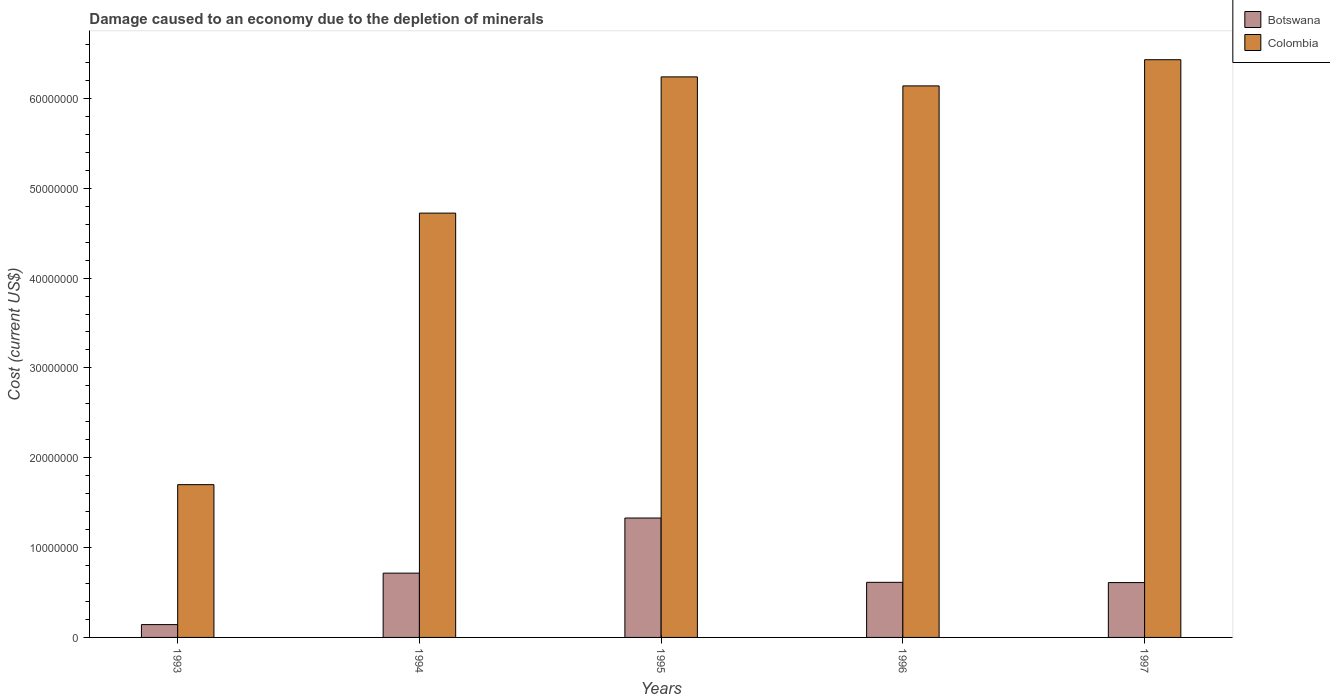What is the label of the 1st group of bars from the left?
Provide a short and direct response. 1993. What is the cost of damage caused due to the depletion of minerals in Botswana in 1993?
Provide a short and direct response. 1.43e+06. Across all years, what is the maximum cost of damage caused due to the depletion of minerals in Botswana?
Ensure brevity in your answer.  1.33e+07. Across all years, what is the minimum cost of damage caused due to the depletion of minerals in Colombia?
Ensure brevity in your answer.  1.70e+07. What is the total cost of damage caused due to the depletion of minerals in Colombia in the graph?
Give a very brief answer. 2.52e+08. What is the difference between the cost of damage caused due to the depletion of minerals in Botswana in 1994 and that in 1996?
Offer a very short reply. 1.02e+06. What is the difference between the cost of damage caused due to the depletion of minerals in Botswana in 1996 and the cost of damage caused due to the depletion of minerals in Colombia in 1994?
Your answer should be compact. -4.11e+07. What is the average cost of damage caused due to the depletion of minerals in Botswana per year?
Provide a short and direct response. 6.82e+06. In the year 1997, what is the difference between the cost of damage caused due to the depletion of minerals in Colombia and cost of damage caused due to the depletion of minerals in Botswana?
Ensure brevity in your answer.  5.82e+07. In how many years, is the cost of damage caused due to the depletion of minerals in Colombia greater than 46000000 US$?
Give a very brief answer. 4. What is the ratio of the cost of damage caused due to the depletion of minerals in Botswana in 1995 to that in 1996?
Make the answer very short. 2.17. Is the difference between the cost of damage caused due to the depletion of minerals in Colombia in 1994 and 1995 greater than the difference between the cost of damage caused due to the depletion of minerals in Botswana in 1994 and 1995?
Provide a short and direct response. No. What is the difference between the highest and the second highest cost of damage caused due to the depletion of minerals in Botswana?
Ensure brevity in your answer.  6.13e+06. What is the difference between the highest and the lowest cost of damage caused due to the depletion of minerals in Colombia?
Ensure brevity in your answer.  4.73e+07. What does the 1st bar from the left in 1997 represents?
Make the answer very short. Botswana. What does the 2nd bar from the right in 1995 represents?
Offer a very short reply. Botswana. How many bars are there?
Give a very brief answer. 10. Are all the bars in the graph horizontal?
Provide a succinct answer. No. Are the values on the major ticks of Y-axis written in scientific E-notation?
Ensure brevity in your answer.  No. Does the graph contain any zero values?
Your answer should be very brief. No. Does the graph contain grids?
Keep it short and to the point. No. How many legend labels are there?
Offer a very short reply. 2. What is the title of the graph?
Give a very brief answer. Damage caused to an economy due to the depletion of minerals. What is the label or title of the Y-axis?
Your answer should be compact. Cost (current US$). What is the Cost (current US$) in Botswana in 1993?
Give a very brief answer. 1.43e+06. What is the Cost (current US$) of Colombia in 1993?
Give a very brief answer. 1.70e+07. What is the Cost (current US$) of Botswana in 1994?
Give a very brief answer. 7.16e+06. What is the Cost (current US$) of Colombia in 1994?
Your answer should be very brief. 4.72e+07. What is the Cost (current US$) of Botswana in 1995?
Offer a very short reply. 1.33e+07. What is the Cost (current US$) of Colombia in 1995?
Provide a succinct answer. 6.24e+07. What is the Cost (current US$) of Botswana in 1996?
Your answer should be compact. 6.13e+06. What is the Cost (current US$) in Colombia in 1996?
Make the answer very short. 6.14e+07. What is the Cost (current US$) in Botswana in 1997?
Give a very brief answer. 6.10e+06. What is the Cost (current US$) of Colombia in 1997?
Offer a terse response. 6.43e+07. Across all years, what is the maximum Cost (current US$) of Botswana?
Provide a short and direct response. 1.33e+07. Across all years, what is the maximum Cost (current US$) in Colombia?
Your answer should be very brief. 6.43e+07. Across all years, what is the minimum Cost (current US$) of Botswana?
Your answer should be compact. 1.43e+06. Across all years, what is the minimum Cost (current US$) of Colombia?
Your response must be concise. 1.70e+07. What is the total Cost (current US$) of Botswana in the graph?
Your answer should be very brief. 3.41e+07. What is the total Cost (current US$) of Colombia in the graph?
Provide a short and direct response. 2.52e+08. What is the difference between the Cost (current US$) in Botswana in 1993 and that in 1994?
Your answer should be very brief. -5.73e+06. What is the difference between the Cost (current US$) of Colombia in 1993 and that in 1994?
Provide a short and direct response. -3.02e+07. What is the difference between the Cost (current US$) of Botswana in 1993 and that in 1995?
Your answer should be very brief. -1.19e+07. What is the difference between the Cost (current US$) in Colombia in 1993 and that in 1995?
Offer a very short reply. -4.54e+07. What is the difference between the Cost (current US$) in Botswana in 1993 and that in 1996?
Offer a very short reply. -4.70e+06. What is the difference between the Cost (current US$) in Colombia in 1993 and that in 1996?
Your answer should be very brief. -4.44e+07. What is the difference between the Cost (current US$) of Botswana in 1993 and that in 1997?
Offer a terse response. -4.68e+06. What is the difference between the Cost (current US$) of Colombia in 1993 and that in 1997?
Make the answer very short. -4.73e+07. What is the difference between the Cost (current US$) of Botswana in 1994 and that in 1995?
Provide a short and direct response. -6.13e+06. What is the difference between the Cost (current US$) in Colombia in 1994 and that in 1995?
Give a very brief answer. -1.52e+07. What is the difference between the Cost (current US$) of Botswana in 1994 and that in 1996?
Keep it short and to the point. 1.02e+06. What is the difference between the Cost (current US$) in Colombia in 1994 and that in 1996?
Provide a short and direct response. -1.42e+07. What is the difference between the Cost (current US$) in Botswana in 1994 and that in 1997?
Ensure brevity in your answer.  1.05e+06. What is the difference between the Cost (current US$) of Colombia in 1994 and that in 1997?
Offer a very short reply. -1.71e+07. What is the difference between the Cost (current US$) of Botswana in 1995 and that in 1996?
Your answer should be very brief. 7.16e+06. What is the difference between the Cost (current US$) in Colombia in 1995 and that in 1996?
Ensure brevity in your answer.  1.00e+06. What is the difference between the Cost (current US$) of Botswana in 1995 and that in 1997?
Make the answer very short. 7.19e+06. What is the difference between the Cost (current US$) in Colombia in 1995 and that in 1997?
Offer a very short reply. -1.91e+06. What is the difference between the Cost (current US$) of Botswana in 1996 and that in 1997?
Your response must be concise. 2.78e+04. What is the difference between the Cost (current US$) in Colombia in 1996 and that in 1997?
Offer a very short reply. -2.91e+06. What is the difference between the Cost (current US$) of Botswana in 1993 and the Cost (current US$) of Colombia in 1994?
Offer a very short reply. -4.58e+07. What is the difference between the Cost (current US$) in Botswana in 1993 and the Cost (current US$) in Colombia in 1995?
Provide a succinct answer. -6.10e+07. What is the difference between the Cost (current US$) in Botswana in 1993 and the Cost (current US$) in Colombia in 1996?
Offer a very short reply. -6.00e+07. What is the difference between the Cost (current US$) of Botswana in 1993 and the Cost (current US$) of Colombia in 1997?
Your answer should be very brief. -6.29e+07. What is the difference between the Cost (current US$) of Botswana in 1994 and the Cost (current US$) of Colombia in 1995?
Offer a very short reply. -5.52e+07. What is the difference between the Cost (current US$) of Botswana in 1994 and the Cost (current US$) of Colombia in 1996?
Your answer should be compact. -5.42e+07. What is the difference between the Cost (current US$) in Botswana in 1994 and the Cost (current US$) in Colombia in 1997?
Offer a terse response. -5.71e+07. What is the difference between the Cost (current US$) of Botswana in 1995 and the Cost (current US$) of Colombia in 1996?
Keep it short and to the point. -4.81e+07. What is the difference between the Cost (current US$) in Botswana in 1995 and the Cost (current US$) in Colombia in 1997?
Provide a short and direct response. -5.10e+07. What is the difference between the Cost (current US$) of Botswana in 1996 and the Cost (current US$) of Colombia in 1997?
Offer a very short reply. -5.82e+07. What is the average Cost (current US$) of Botswana per year?
Keep it short and to the point. 6.82e+06. What is the average Cost (current US$) of Colombia per year?
Ensure brevity in your answer.  5.05e+07. In the year 1993, what is the difference between the Cost (current US$) in Botswana and Cost (current US$) in Colombia?
Give a very brief answer. -1.56e+07. In the year 1994, what is the difference between the Cost (current US$) in Botswana and Cost (current US$) in Colombia?
Ensure brevity in your answer.  -4.01e+07. In the year 1995, what is the difference between the Cost (current US$) in Botswana and Cost (current US$) in Colombia?
Make the answer very short. -4.91e+07. In the year 1996, what is the difference between the Cost (current US$) in Botswana and Cost (current US$) in Colombia?
Your response must be concise. -5.53e+07. In the year 1997, what is the difference between the Cost (current US$) of Botswana and Cost (current US$) of Colombia?
Provide a short and direct response. -5.82e+07. What is the ratio of the Cost (current US$) in Botswana in 1993 to that in 1994?
Ensure brevity in your answer.  0.2. What is the ratio of the Cost (current US$) of Colombia in 1993 to that in 1994?
Your response must be concise. 0.36. What is the ratio of the Cost (current US$) of Botswana in 1993 to that in 1995?
Offer a terse response. 0.11. What is the ratio of the Cost (current US$) of Colombia in 1993 to that in 1995?
Your answer should be very brief. 0.27. What is the ratio of the Cost (current US$) of Botswana in 1993 to that in 1996?
Make the answer very short. 0.23. What is the ratio of the Cost (current US$) of Colombia in 1993 to that in 1996?
Provide a succinct answer. 0.28. What is the ratio of the Cost (current US$) of Botswana in 1993 to that in 1997?
Ensure brevity in your answer.  0.23. What is the ratio of the Cost (current US$) of Colombia in 1993 to that in 1997?
Your answer should be compact. 0.26. What is the ratio of the Cost (current US$) in Botswana in 1994 to that in 1995?
Make the answer very short. 0.54. What is the ratio of the Cost (current US$) of Colombia in 1994 to that in 1995?
Keep it short and to the point. 0.76. What is the ratio of the Cost (current US$) in Botswana in 1994 to that in 1996?
Make the answer very short. 1.17. What is the ratio of the Cost (current US$) of Colombia in 1994 to that in 1996?
Ensure brevity in your answer.  0.77. What is the ratio of the Cost (current US$) of Botswana in 1994 to that in 1997?
Offer a terse response. 1.17. What is the ratio of the Cost (current US$) of Colombia in 1994 to that in 1997?
Give a very brief answer. 0.73. What is the ratio of the Cost (current US$) in Botswana in 1995 to that in 1996?
Your response must be concise. 2.17. What is the ratio of the Cost (current US$) of Colombia in 1995 to that in 1996?
Your response must be concise. 1.02. What is the ratio of the Cost (current US$) of Botswana in 1995 to that in 1997?
Ensure brevity in your answer.  2.18. What is the ratio of the Cost (current US$) in Colombia in 1995 to that in 1997?
Your answer should be compact. 0.97. What is the ratio of the Cost (current US$) of Colombia in 1996 to that in 1997?
Provide a succinct answer. 0.95. What is the difference between the highest and the second highest Cost (current US$) in Botswana?
Keep it short and to the point. 6.13e+06. What is the difference between the highest and the second highest Cost (current US$) in Colombia?
Offer a terse response. 1.91e+06. What is the difference between the highest and the lowest Cost (current US$) in Botswana?
Ensure brevity in your answer.  1.19e+07. What is the difference between the highest and the lowest Cost (current US$) in Colombia?
Your answer should be very brief. 4.73e+07. 